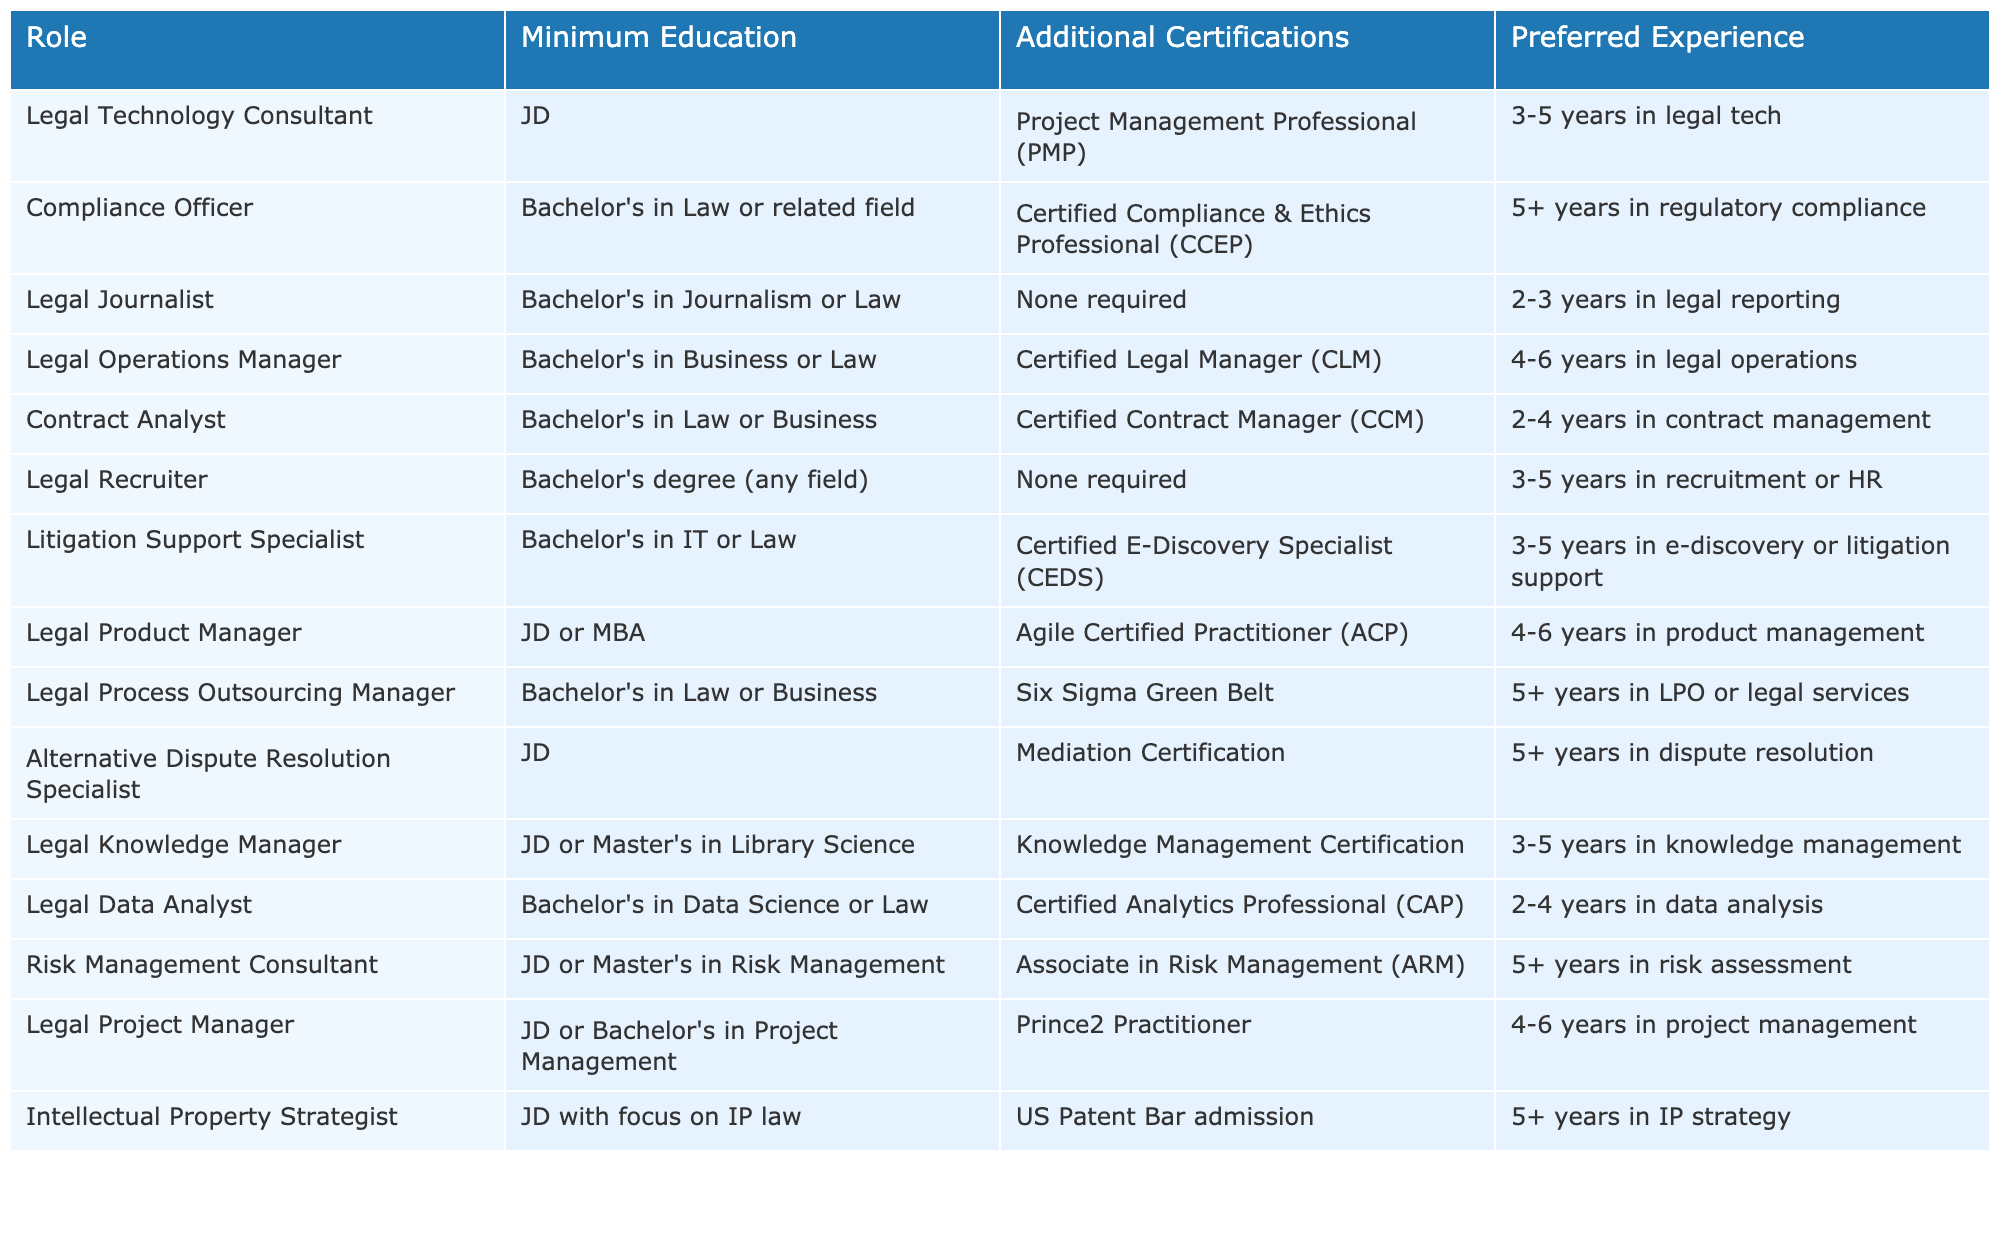What is the minimum educational requirement for a Legal Technology Consultant? The table lists the minimum educational requirement for a Legal Technology Consultant as a JD.
Answer: JD How many years of experience are preferred for the Compliance Officer role? According to the table, the preferred experience for a Compliance Officer is 5 or more years in regulatory compliance.
Answer: 5+ years Which role requires a Certified Legal Manager certification? The table indicates that the Legal Operations Manager role requires this certification.
Answer: Legal Operations Manager Is a Bachelor's in Law sufficient for a Contract Analyst role? Yes, the table specifies that a Bachelor's in Law or Business is the minimum education required for this role.
Answer: Yes What is the additional certification needed for a Legal Data Analyst? The table shows that a Certified Analytics Professional (CAP) is the additional certification required.
Answer: Certified Analytics Professional (CAP) How many roles require a JD as the minimum education? The table lists five roles that require a JD, specifically for the Legal Technology Consultant, Alternative Dispute Resolution Specialist, Intellectual Property Strategist, Legal Knowledge Manager, and Legal Project Manager.
Answer: 5 Is there any role listed that does not require any additional certifications? Yes, the Legal Recruiter and Legal Journalist roles are listed with no additional certifications required.
Answer: Yes What is the relationship between the number of years of preferred experience and the educational level for the Legal Product Manager? The Legal Product Manager role requires a JD or MBA and 4 to 6 years of product management experience, indicating that a higher education level is coupled with a moderate amount of experience.
Answer: Higher education, moderate experience Which role has the longest preferred work experience requirement, and how many years is it? The Compliance Officer role has the longest preferred experience requirement of 5 or more years in regulatory compliance.
Answer: Compliance Officer, 5+ years Does a Legal Recruiter require a specific field of study for their Bachelor's degree? No, the table indicates that a Bachelor's degree in any field is acceptable for the Legal Recruiter role.
Answer: No 